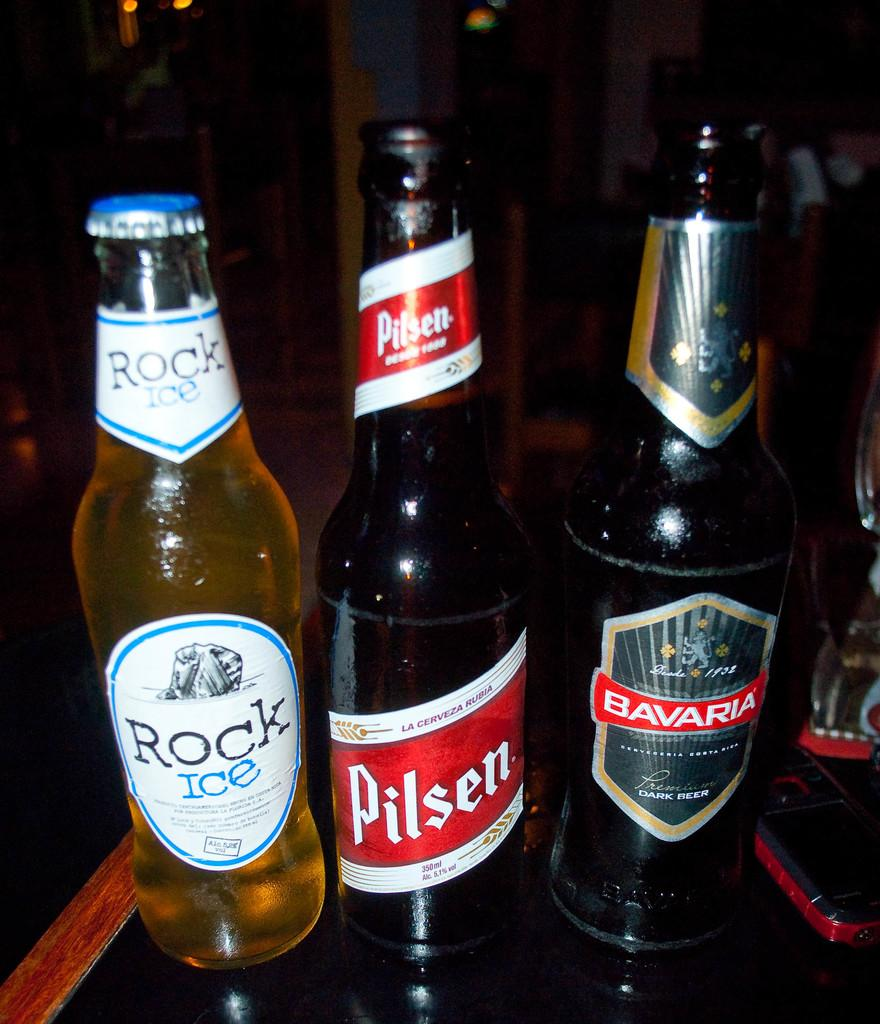<image>
Create a compact narrative representing the image presented. Three beer bottles including Rock Ice and Pilsen. 